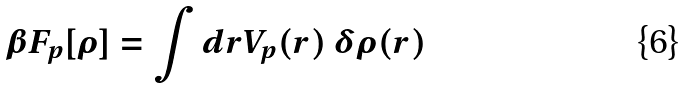Convert formula to latex. <formula><loc_0><loc_0><loc_500><loc_500>\beta F _ { p } [ \rho ] = \int { d { r } V _ { p } ( { r } ) \, \delta \rho ( { r } ) }</formula> 